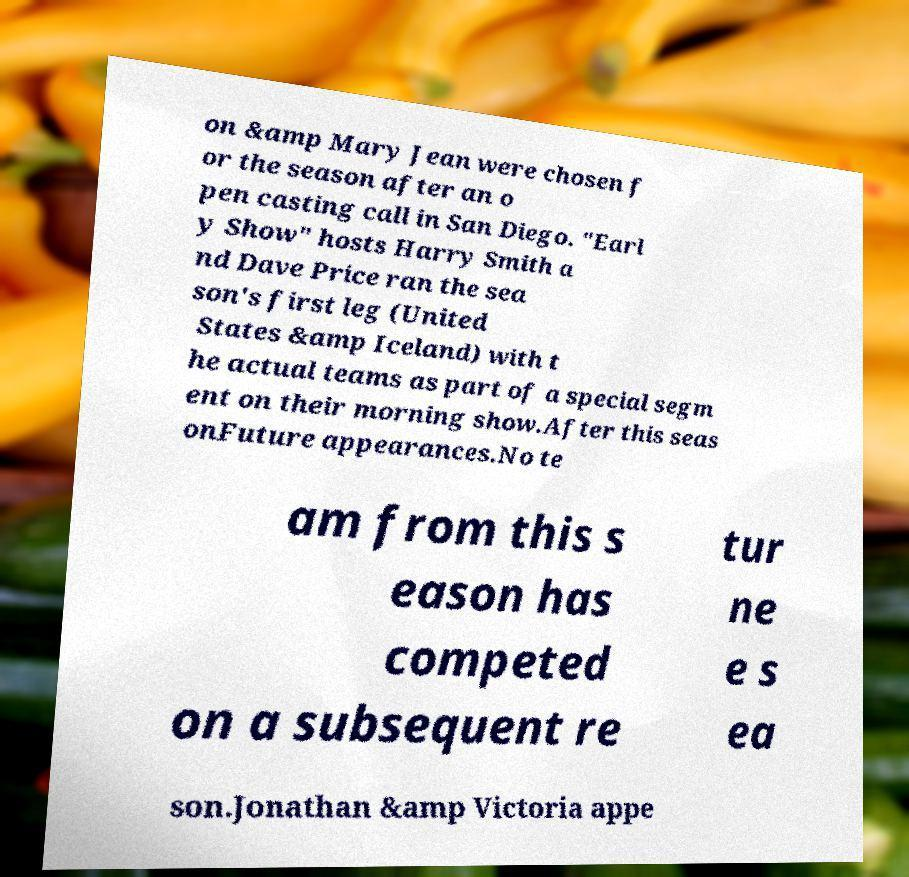I need the written content from this picture converted into text. Can you do that? on &amp Mary Jean were chosen f or the season after an o pen casting call in San Diego. "Earl y Show" hosts Harry Smith a nd Dave Price ran the sea son's first leg (United States &amp Iceland) with t he actual teams as part of a special segm ent on their morning show.After this seas onFuture appearances.No te am from this s eason has competed on a subsequent re tur ne e s ea son.Jonathan &amp Victoria appe 